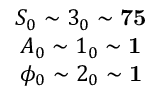<formula> <loc_0><loc_0><loc_500><loc_500>\begin{array} { c } { { S _ { 0 } \sim 3 _ { 0 } \sim 7 5 } } \\ { { A _ { 0 } \sim 1 _ { 0 } \sim 1 } } \\ { { \phi _ { 0 } \sim 2 _ { 0 } \sim 1 } } \end{array}</formula> 